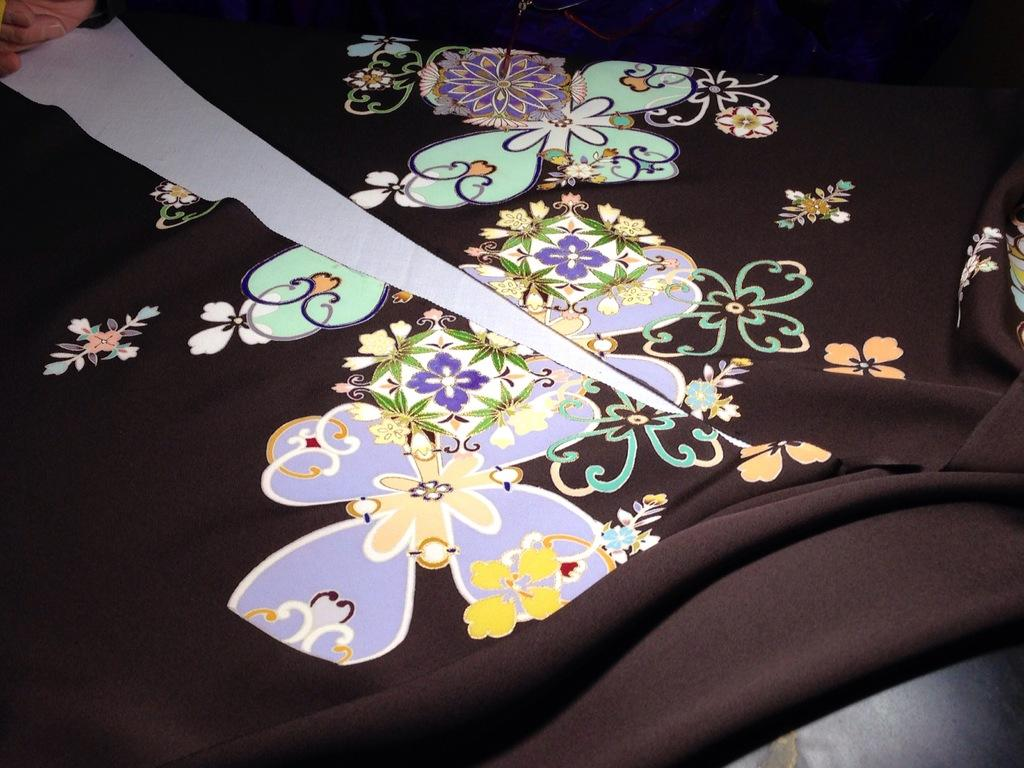What is the color of the cloth in the image? The cloth in the image is black. Are there any patterns or designs on the cloth? Yes, the cloth has designs on it. How is the cloth positioned or altered in the image? The cloth is cut in the middle. How does the pin hold the cloth in the image? There is no pin present in the image; the cloth is cut in the middle. 